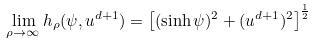<formula> <loc_0><loc_0><loc_500><loc_500>\lim _ { \rho \to \infty } h _ { \rho } ( \psi , u ^ { d + 1 } ) = \left [ ( \sinh \psi ) ^ { 2 } + ( u ^ { d + 1 } ) ^ { 2 } \right ] ^ { \frac { 1 } { 2 } }</formula> 